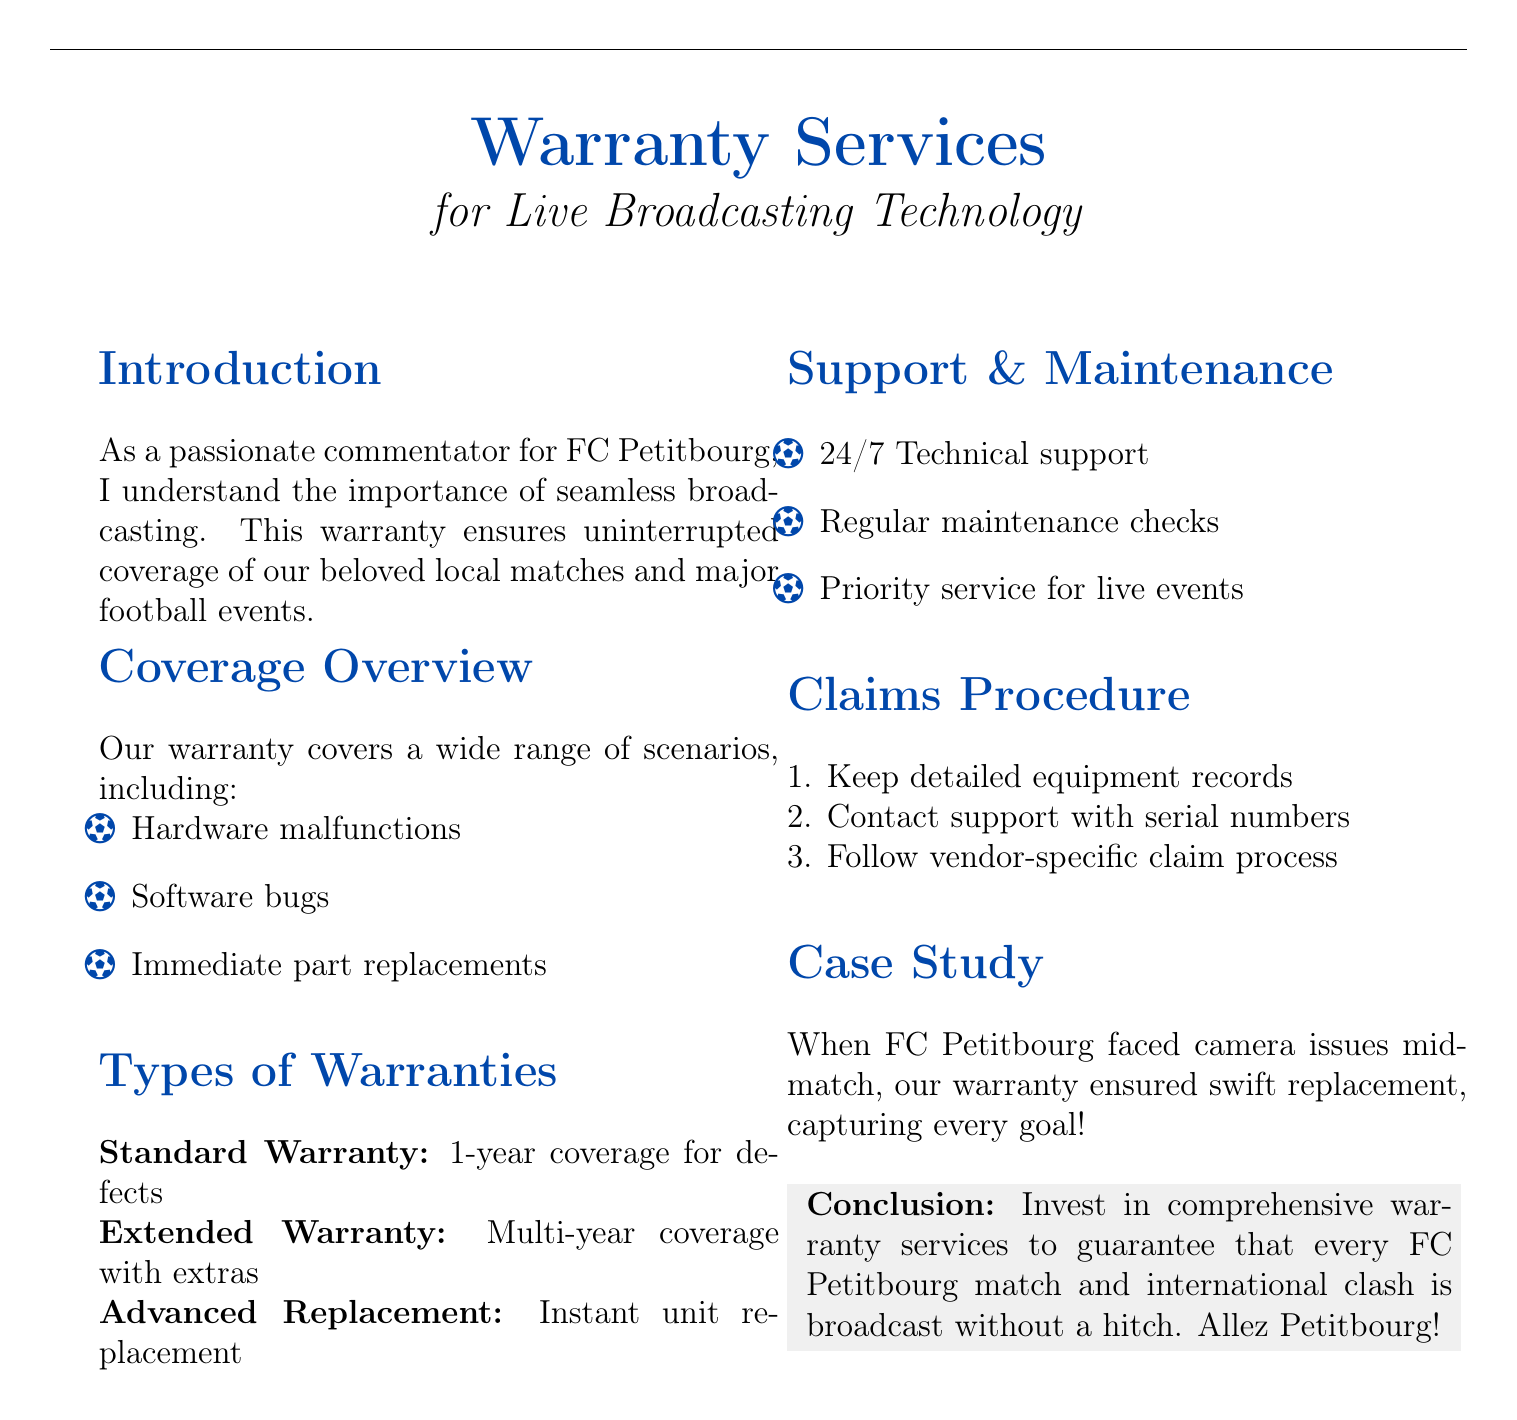What does the warranty ensure? The warranty ensures uninterrupted coverage of local matches and major football events.
Answer: Uninterrupted coverage What is the duration of the Standard Warranty? The Standard Warranty provides 1-year coverage for defects.
Answer: 1-year What kind of support is available 24/7? The warranty offers 24/7 Technical support.
Answer: Technical support What will happen during a live event if an issue arises? There is priority service for live events.
Answer: Priority service What should you keep for the claims procedure? You should keep detailed equipment records.
Answer: Equipment records What is a specific type of warranty offered? The document mentions an Advanced Replacement warranty.
Answer: Advanced Replacement What issue did FC Petitbourg face during a match? FC Petitbourg faced camera issues mid-match.
Answer: Camera issues Which warranty type offers multi-year coverage? The Extended Warranty offers multi-year coverage with extras.
Answer: Extended Warranty What is the color of the section headings? The section headings are in a specific blue color.
Answer: Petitbourg blue 